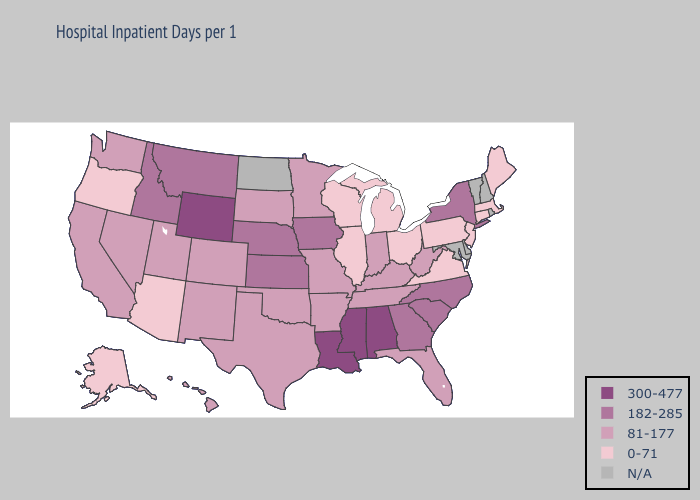Among the states that border Colorado , which have the highest value?
Be succinct. Wyoming. What is the highest value in the Northeast ?
Give a very brief answer. 182-285. What is the highest value in states that border Texas?
Short answer required. 300-477. Name the states that have a value in the range N/A?
Give a very brief answer. Delaware, Maryland, New Hampshire, North Dakota, Rhode Island, Vermont. Name the states that have a value in the range 0-71?
Keep it brief. Alaska, Arizona, Connecticut, Illinois, Maine, Massachusetts, Michigan, New Jersey, Ohio, Oregon, Pennsylvania, Virginia, Wisconsin. What is the value of Louisiana?
Write a very short answer. 300-477. Does Alabama have the highest value in the USA?
Write a very short answer. Yes. Does Wisconsin have the lowest value in the USA?
Answer briefly. Yes. What is the value of Oregon?
Answer briefly. 0-71. What is the value of Colorado?
Quick response, please. 81-177. Name the states that have a value in the range 300-477?
Concise answer only. Alabama, Louisiana, Mississippi, Wyoming. Does Nebraska have the lowest value in the MidWest?
Write a very short answer. No. 